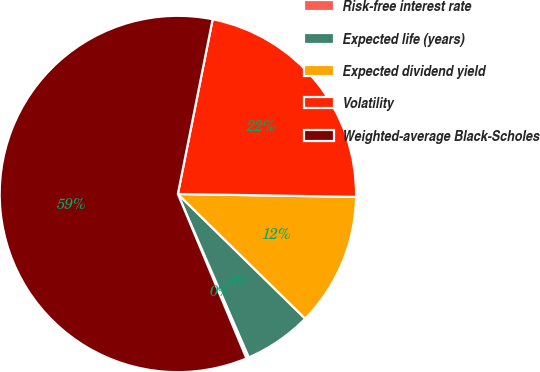Convert chart. <chart><loc_0><loc_0><loc_500><loc_500><pie_chart><fcel>Risk-free interest rate<fcel>Expected life (years)<fcel>Expected dividend yield<fcel>Volatility<fcel>Weighted-average Black-Scholes<nl><fcel>0.23%<fcel>6.15%<fcel>12.07%<fcel>22.13%<fcel>59.42%<nl></chart> 